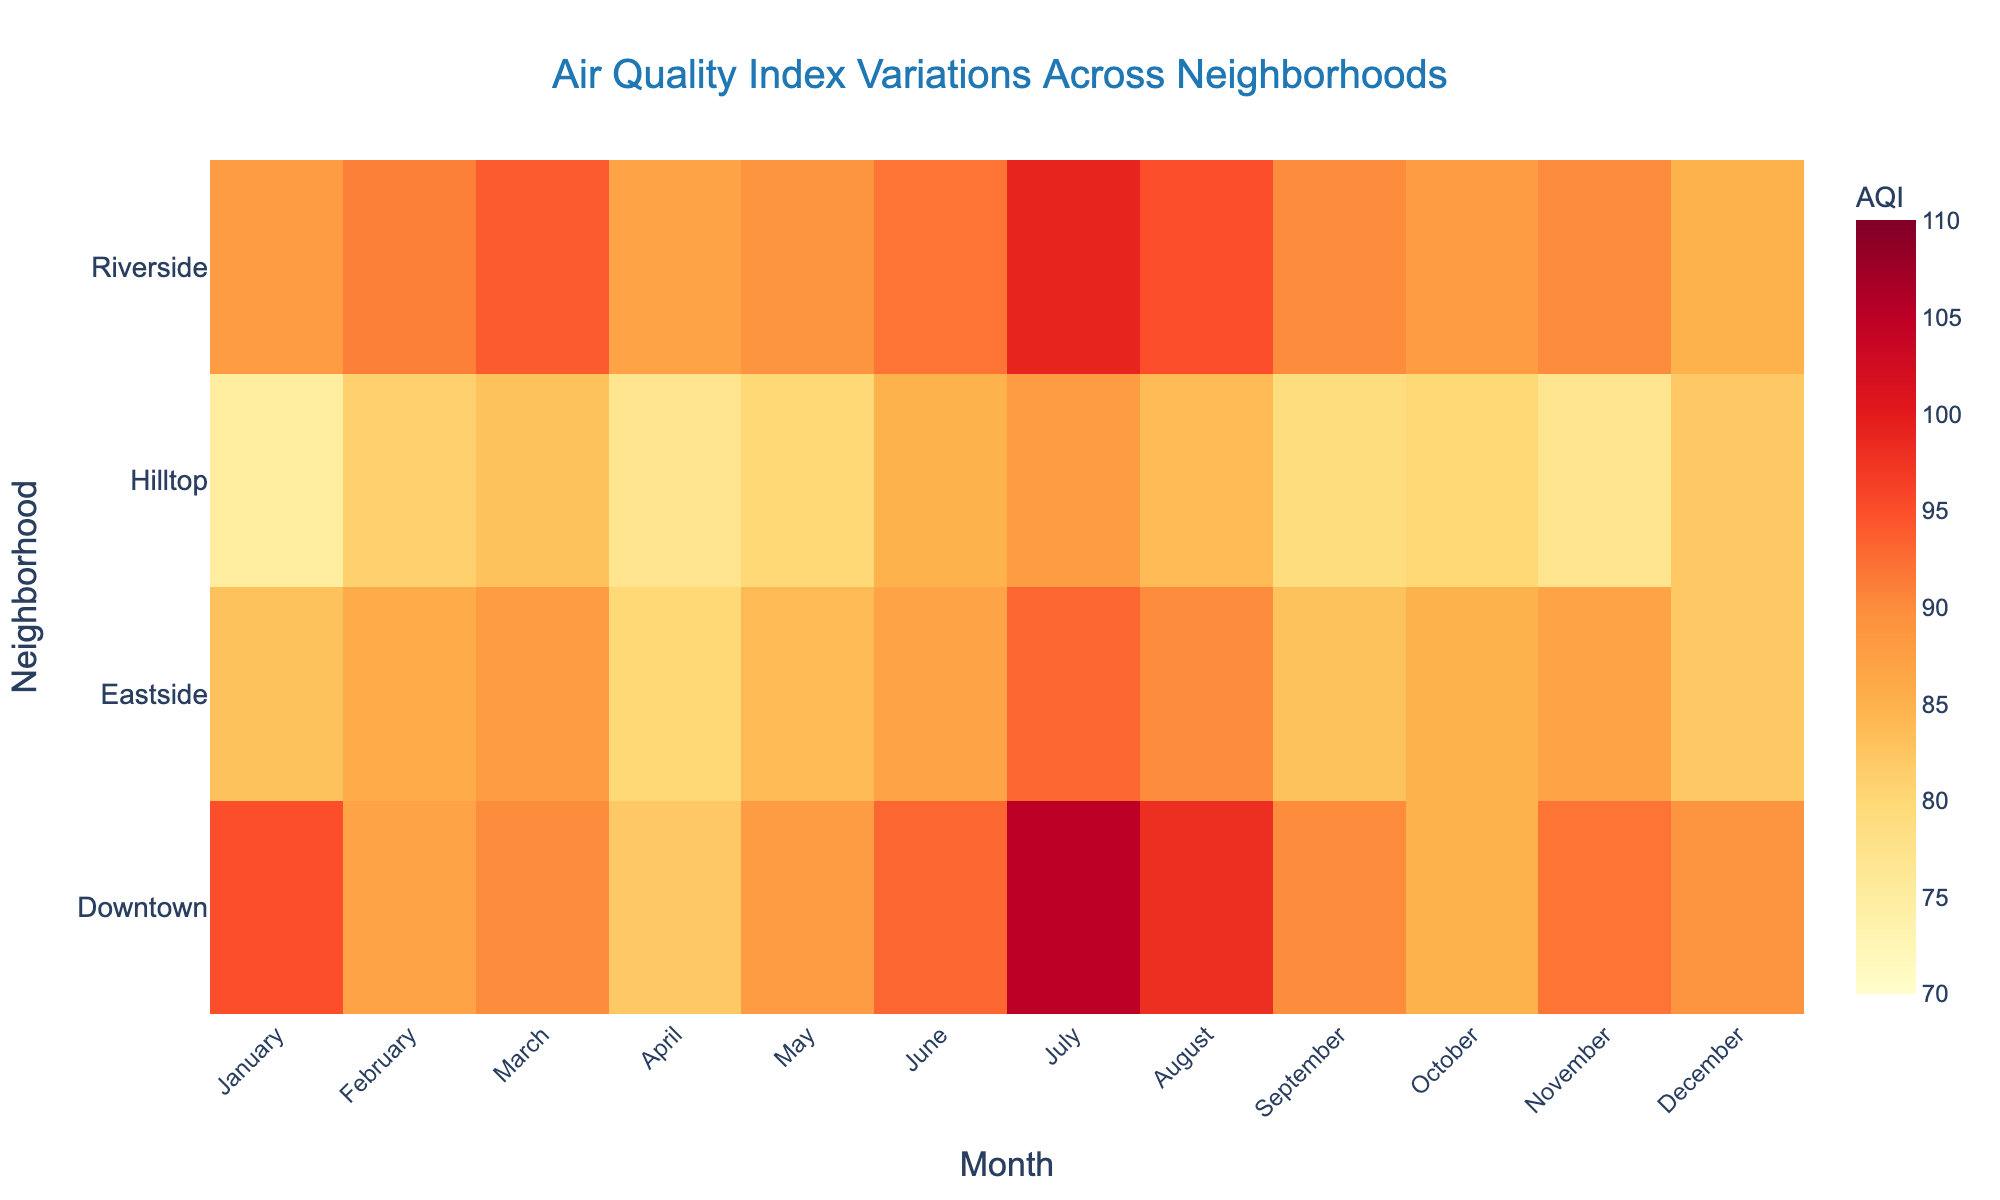How many neighborhoods are represented in the heatmap? The figure displays each neighborhood on the y-axis. By counting them, we see "Downtown", "Hilltop", "Riverside", and "Eastside", totaling four neighborhoods.
Answer: Four Which month has the highest AQI in Downtown? Locate Downtown's row and compare AQI values across each month. July has the highest value with an AQI of 105.
Answer: July What is the average AQI for Hilltop across the year? Sum Hilltop's monthly AQI values: 75+81+83+77+80+85+88+84+79+80+77+82 = 971. Divide by 12 to get the average: 971/12 ≈ 81
Answer: 81 Is there a month where all neighborhoods have an AQI less than 90? Check each month to see if all neighborhoods' AQI values are below 90. No single month has all values below 90.
Answer: No Which neighborhood has the highest average AQI for the year? Calculate the average AQI for each neighborhood: Downtown = 94.25, Hilltop = 80.92, Riverside = 90.67, Eastside = 85.67. Downtown has the highest average.
Answer: Downtown During which month does Riverside have the lowest AQI? Review Riverside's row, and identify the lowest AQI value, which is 85 in December.
Answer: December Compare the average AQI in August across all neighborhoods. Which has the lowest? Calculate the August AQI average for each neighborhood: Downtown = 98, Hilltop = 84, Riverside = 95, Eastside = 90. Hilltop has the lowest AVG.
Answer: Hilltop What trend can be observed in Downtown’s AQI from April to July? Examine Downtown’s AQI values: increasing from 82 (April) to 93 (June) to 105 (July). So the trend is rising.
Answer: Rising Which month has the highest AQI overall across all neighborhoods? Identify the highest AQI value for each month across all neighborhoods: July in Downtown reaches 105, the highest for any month.
Answer: July 